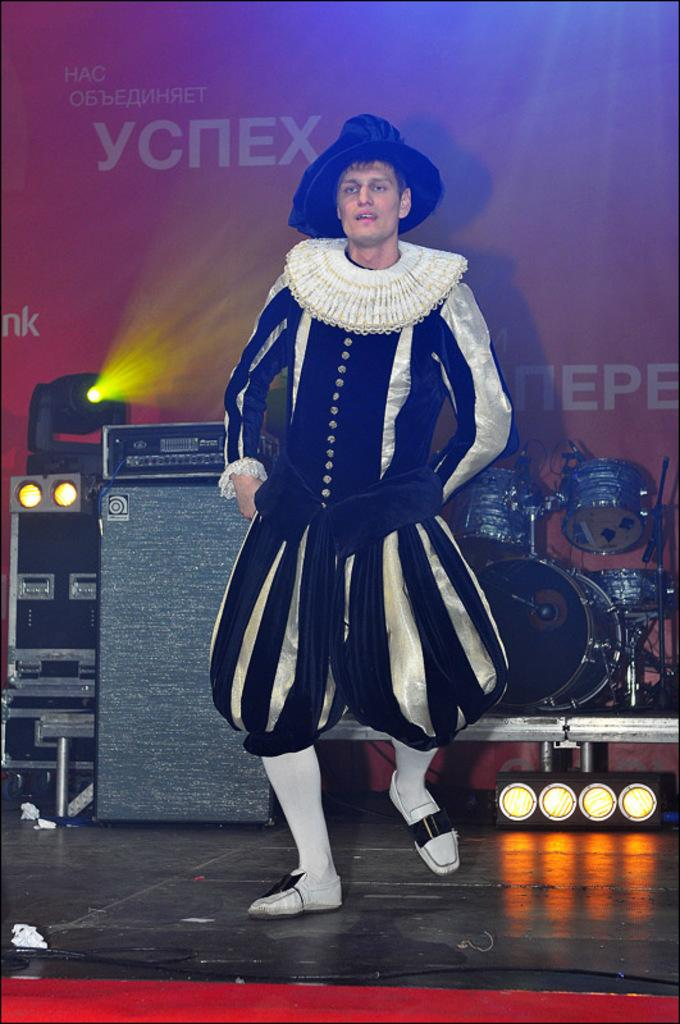What is the main subject of the image? There is a man dancing in the center of the image. What can be seen in the background of the image? There are musical instruments, lights, and a board with text written on it in the background. What might be the purpose of the board with text in the background? The board with text might be used for announcements or information related to the event or performance. How many jellyfish are floating in the air in the image? There are no jellyfish present in the image. What type of ball is being used by the man while dancing? The image does not show the man using a ball while dancing. 